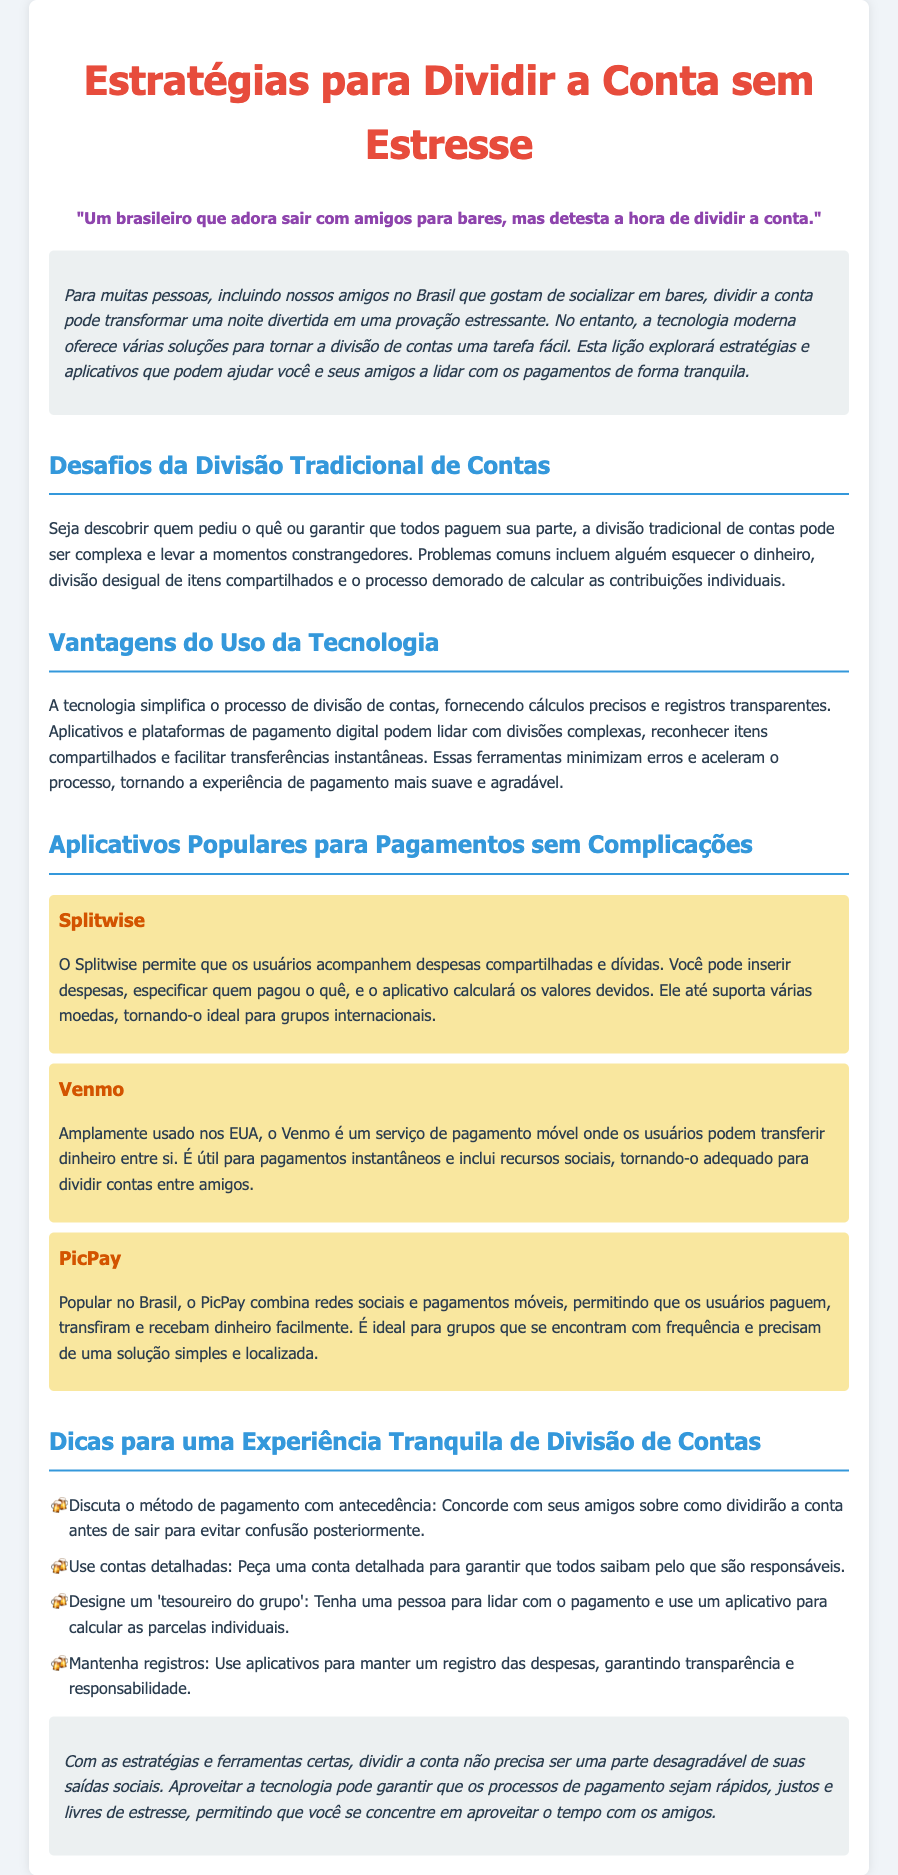Qual é o título do documento? O título do documento é explicitamente mencionado no cabeçalho da página e é "Estratégias para Dividir a Conta sem Estresse".
Answer: Estratégias para Dividir a Conta sem Estresse Qual aplicativo é popular no Brasil para pagamentos móveis? O documento menciona que o PicPay é um aplicativo popular no Brasil para pagamentos móveis.
Answer: PicPay Quem é o público-alvo desta lição? O público-alvo é descrito em uma citação no documento que se refere a um brasileiro que gosta de sair com amigos.
Answer: Um brasileiro que adora sair com amigos para bares Quais são as vantagens de usar tecnologia ao dividir contas? No texto, é mencionado que a tecnologia simplifica a divisão de contas fazendo cálculos precisos e registros transparentes.
Answer: Cálculos precisos e registros transparentes Qual é uma das dicas para uma experiência tranquila de divisão de contas? O documento lista várias dicas, incluindo discutir o método de pagamento com antecedência.
Answer: Discuta o método de pagamento com antecedência Quantos aplicativos são destacados no documento? O texto menciona três aplicativos diferentes utilizados para facilitar a divisão da conta.
Answer: Três O que o Splitwise permite que os usuários façam? O documento afirma que o Splitwise permite que os usuários acompanhem despesas compartilhadas e dívidas.
Answer: Acompanhem despesas compartilhadas e dívidas Qual é um dos desafios da divisão tradicional de contas? O documento lista que um dos problemas é a divisão desigual de itens compartilhados.
Answer: Divisão desigual de itens compartilhados 